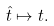<formula> <loc_0><loc_0><loc_500><loc_500>\hat { t } \mapsto t .</formula> 